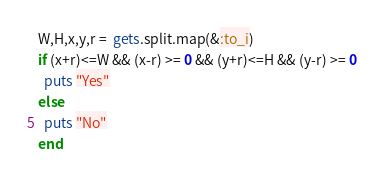<code> <loc_0><loc_0><loc_500><loc_500><_Ruby_>W,H,x,y,r =  gets.split.map(&:to_i)
if (x+r)<=W && (x-r) >= 0 && (y+r)<=H && (y-r) >= 0
  puts "Yes"
else
  puts "No"
end

</code> 